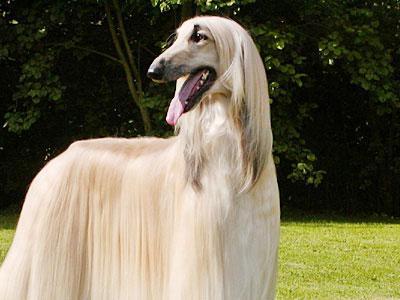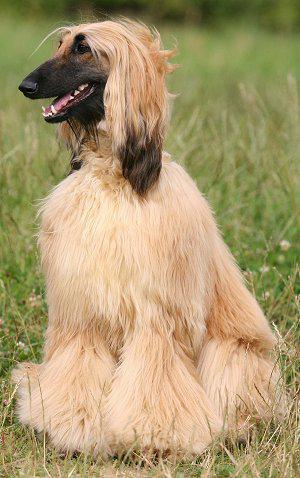The first image is the image on the left, the second image is the image on the right. Examine the images to the left and right. Is the description "Four dog feet are visible in the image on the left." accurate? Answer yes or no. No. 